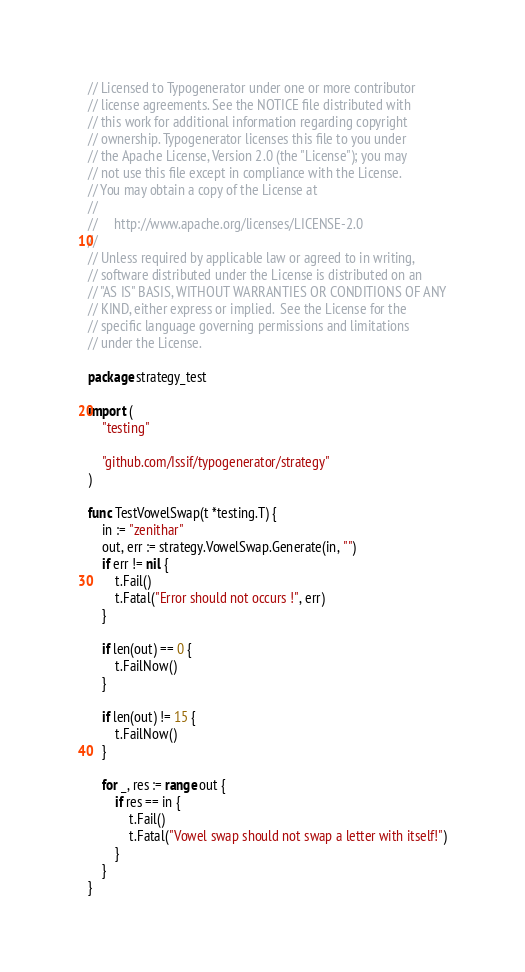Convert code to text. <code><loc_0><loc_0><loc_500><loc_500><_Go_>// Licensed to Typogenerator under one or more contributor
// license agreements. See the NOTICE file distributed with
// this work for additional information regarding copyright
// ownership. Typogenerator licenses this file to you under
// the Apache License, Version 2.0 (the "License"); you may
// not use this file except in compliance with the License.
// You may obtain a copy of the License at
//
//     http://www.apache.org/licenses/LICENSE-2.0
//
// Unless required by applicable law or agreed to in writing,
// software distributed under the License is distributed on an
// "AS IS" BASIS, WITHOUT WARRANTIES OR CONDITIONS OF ANY
// KIND, either express or implied.  See the License for the
// specific language governing permissions and limitations
// under the License.

package strategy_test

import (
	"testing"

	"github.com/Issif/typogenerator/strategy"
)

func TestVowelSwap(t *testing.T) {
	in := "zenithar"
	out, err := strategy.VowelSwap.Generate(in, "")
	if err != nil {
		t.Fail()
		t.Fatal("Error should not occurs !", err)
	}

	if len(out) == 0 {
		t.FailNow()
	}

	if len(out) != 15 {
		t.FailNow()
	}

	for _, res := range out {
		if res == in {
			t.Fail()
			t.Fatal("Vowel swap should not swap a letter with itself!")
		}
	}
}
</code> 